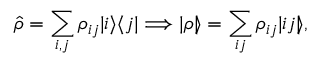Convert formula to latex. <formula><loc_0><loc_0><loc_500><loc_500>\hat { \rho } = \sum _ { i , j } \rho _ { i j } | i \rangle \langle j | \Longrightarrow | \rho \ r r a n g l e = \sum _ { i j } \rho _ { i j } | i j \ r r a n g l e ,</formula> 